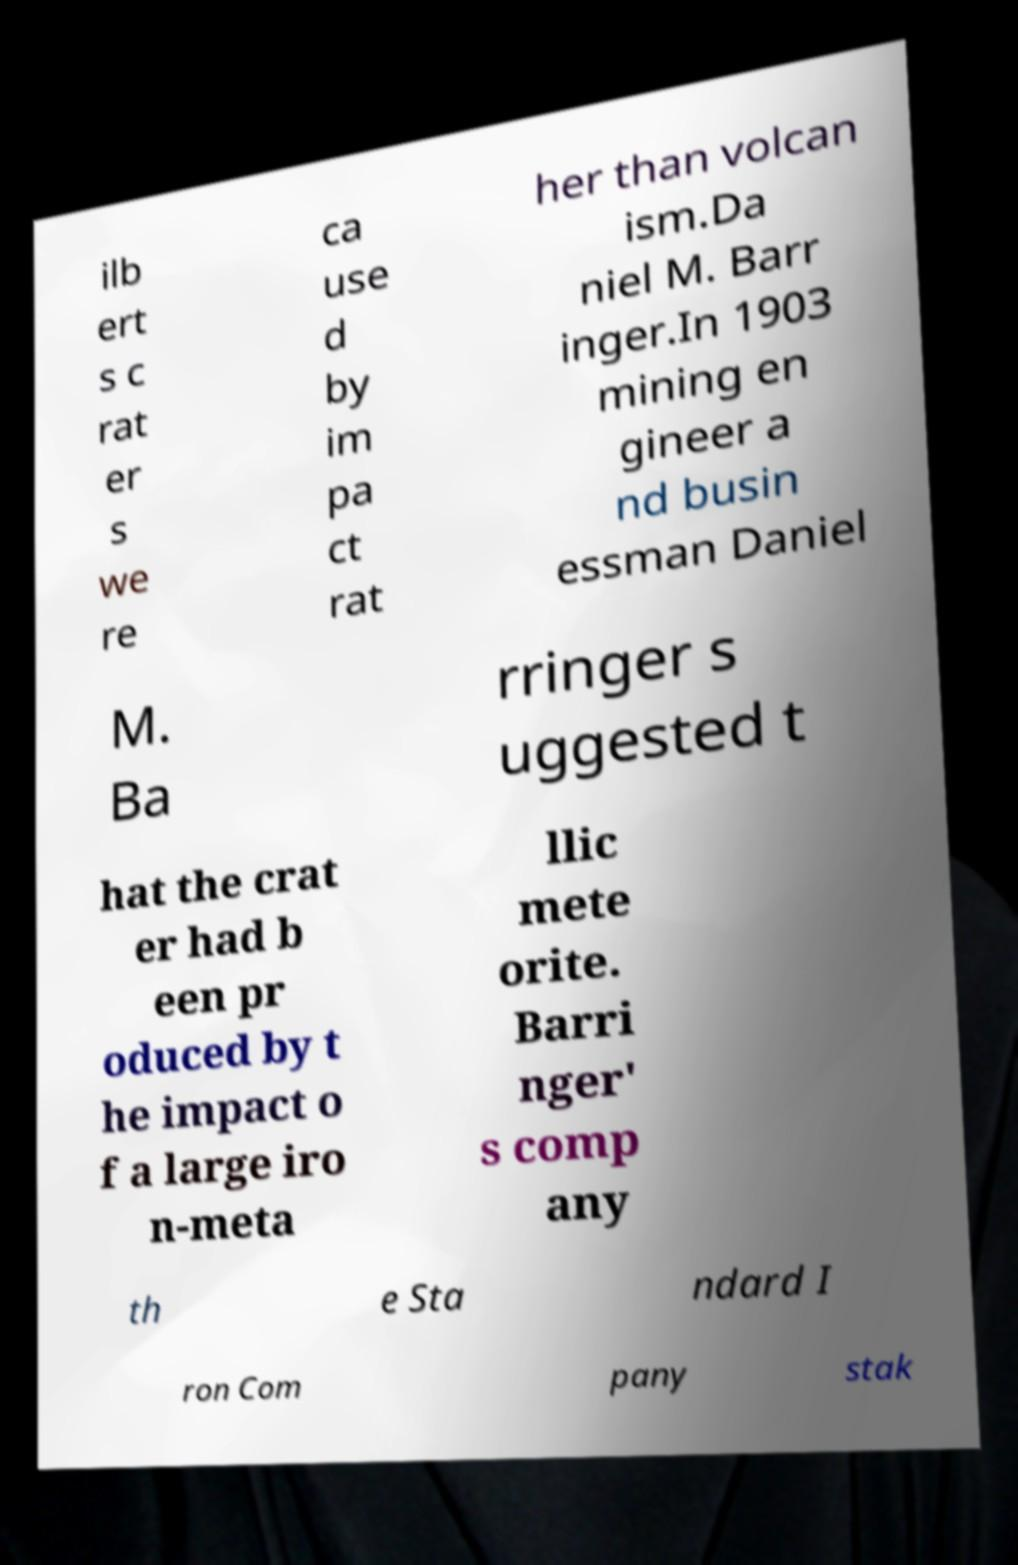Please identify and transcribe the text found in this image. ilb ert s c rat er s we re ca use d by im pa ct rat her than volcan ism.Da niel M. Barr inger.In 1903 mining en gineer a nd busin essman Daniel M. Ba rringer s uggested t hat the crat er had b een pr oduced by t he impact o f a large iro n-meta llic mete orite. Barri nger' s comp any th e Sta ndard I ron Com pany stak 